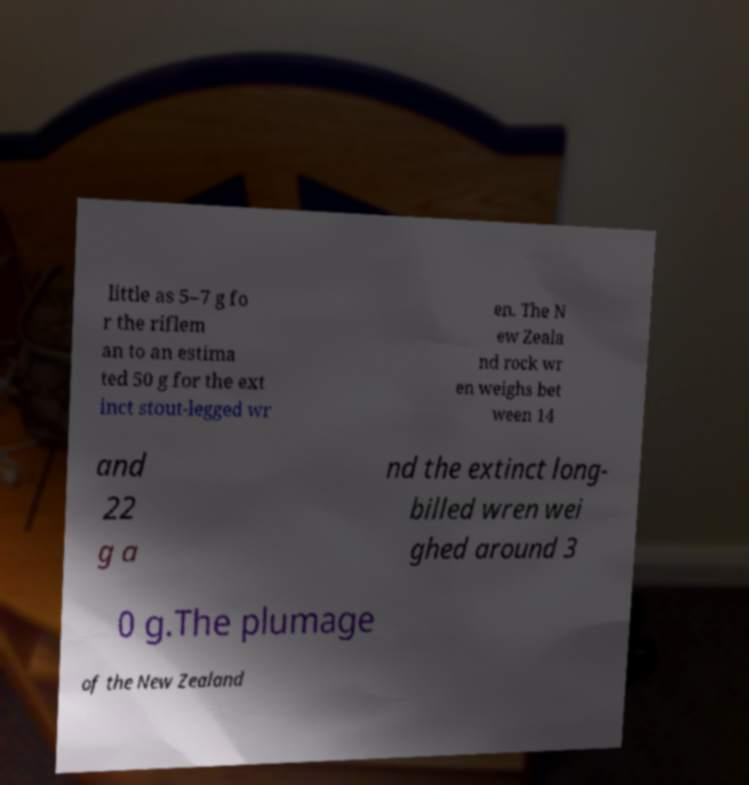Please identify and transcribe the text found in this image. little as 5–7 g fo r the riflem an to an estima ted 50 g for the ext inct stout-legged wr en. The N ew Zeala nd rock wr en weighs bet ween 14 and 22 g a nd the extinct long- billed wren wei ghed around 3 0 g.The plumage of the New Zealand 